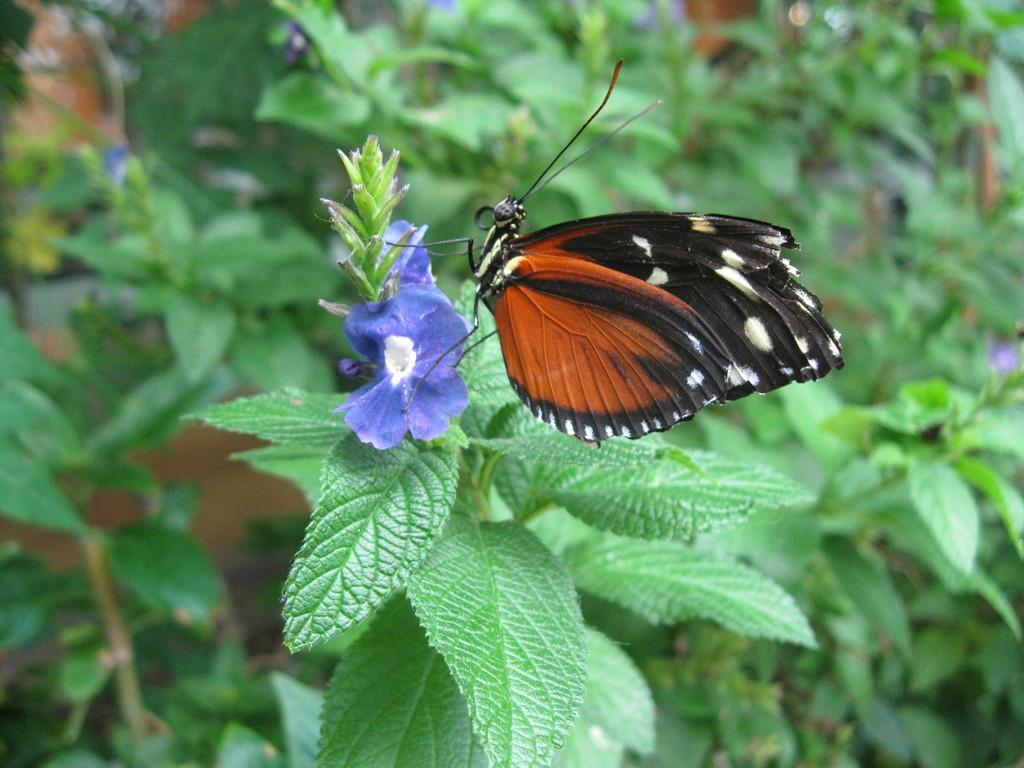What is the main subject of the image? There is a butterfly on a plant in the image. Can you describe the plant that the butterfly is on? Unfortunately, the facts provided do not give any details about the plant. What can be seen in the background of the image? The background of the image is blurred. What religion is practiced by the butterfly in the image? There is no indication of religion in the image, as it features a butterfly on a plant. 